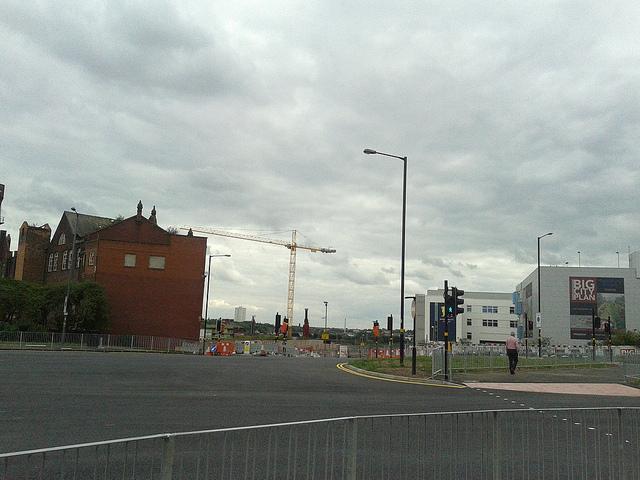What is the yellow structure in the background used for?
Answer the question by selecting the correct answer among the 4 following choices and explain your choice with a short sentence. The answer should be formatted with the following format: `Answer: choice
Rationale: rationale.`
Options: Lifting things, throwing things, climbing, holding things. Answer: lifting things.
Rationale: The structure lifts. 